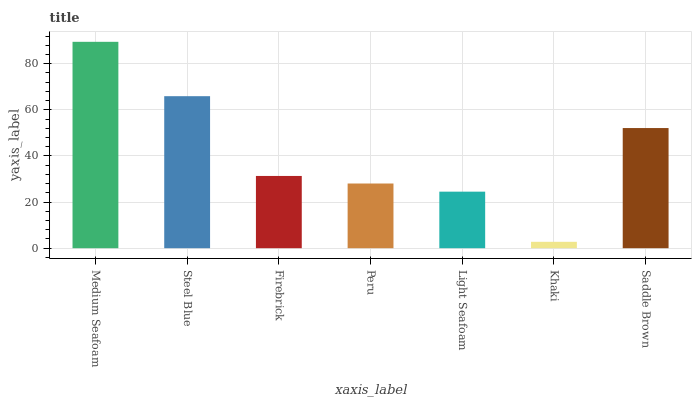Is Khaki the minimum?
Answer yes or no. Yes. Is Medium Seafoam the maximum?
Answer yes or no. Yes. Is Steel Blue the minimum?
Answer yes or no. No. Is Steel Blue the maximum?
Answer yes or no. No. Is Medium Seafoam greater than Steel Blue?
Answer yes or no. Yes. Is Steel Blue less than Medium Seafoam?
Answer yes or no. Yes. Is Steel Blue greater than Medium Seafoam?
Answer yes or no. No. Is Medium Seafoam less than Steel Blue?
Answer yes or no. No. Is Firebrick the high median?
Answer yes or no. Yes. Is Firebrick the low median?
Answer yes or no. Yes. Is Khaki the high median?
Answer yes or no. No. Is Light Seafoam the low median?
Answer yes or no. No. 